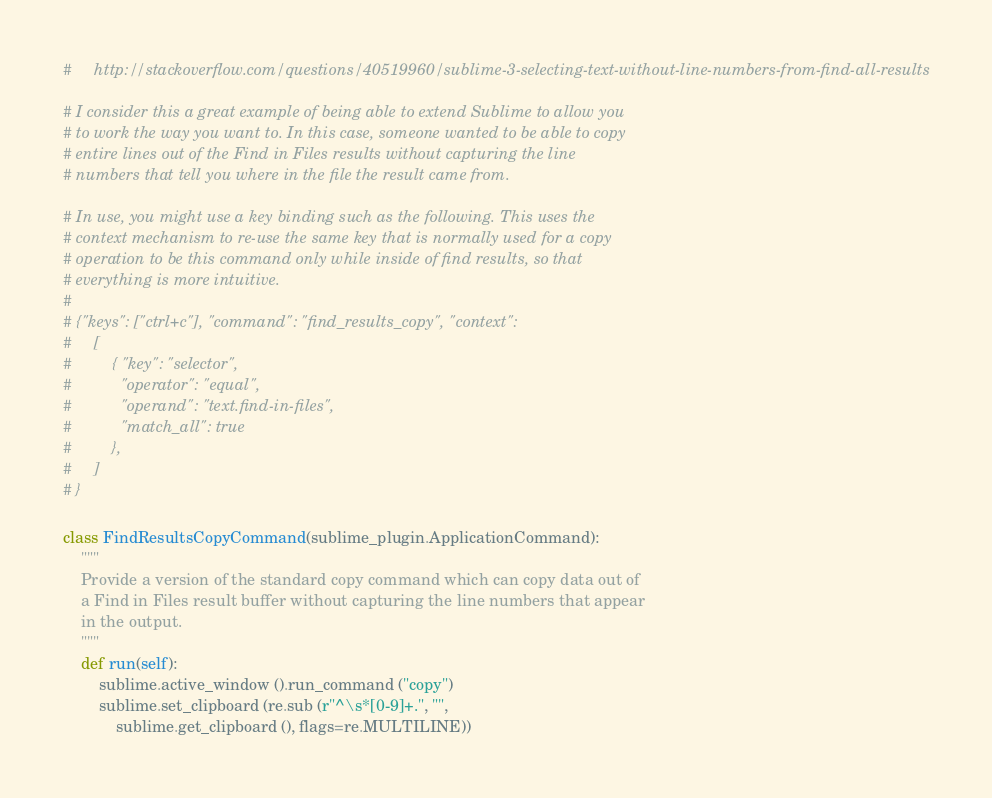<code> <loc_0><loc_0><loc_500><loc_500><_Python_>#     http://stackoverflow.com/questions/40519960/sublime-3-selecting-text-without-line-numbers-from-find-all-results

# I consider this a great example of being able to extend Sublime to allow you
# to work the way you want to. In this case, someone wanted to be able to copy
# entire lines out of the Find in Files results without capturing the line
# numbers that tell you where in the file the result came from.

# In use, you might use a key binding such as the following. This uses the
# context mechanism to re-use the same key that is normally used for a copy
# operation to be this command only while inside of find results, so that
# everything is more intuitive.
#
# {"keys": ["ctrl+c"], "command": "find_results_copy", "context":
#     [
#         { "key": "selector",
#           "operator": "equal",
#           "operand": "text.find-in-files",
#           "match_all": true
#         },
#     ]
# }

class FindResultsCopyCommand(sublime_plugin.ApplicationCommand):
    """
    Provide a version of the standard copy command which can copy data out of
    a Find in Files result buffer without capturing the line numbers that appear
    in the output.
    """
    def run(self):
        sublime.active_window ().run_command ("copy")
        sublime.set_clipboard (re.sub (r"^\s*[0-9]+.", "",
            sublime.get_clipboard (), flags=re.MULTILINE))</code> 